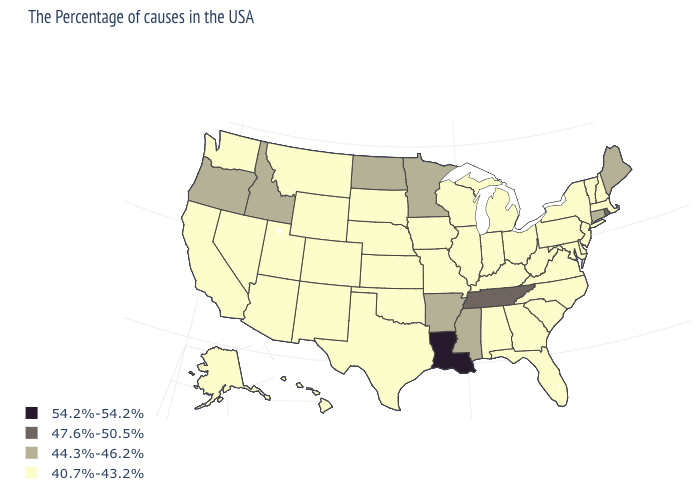Which states have the lowest value in the West?
Give a very brief answer. Wyoming, Colorado, New Mexico, Utah, Montana, Arizona, Nevada, California, Washington, Alaska, Hawaii. What is the value of Ohio?
Write a very short answer. 40.7%-43.2%. Name the states that have a value in the range 40.7%-43.2%?
Short answer required. Massachusetts, New Hampshire, Vermont, New York, New Jersey, Delaware, Maryland, Pennsylvania, Virginia, North Carolina, South Carolina, West Virginia, Ohio, Florida, Georgia, Michigan, Kentucky, Indiana, Alabama, Wisconsin, Illinois, Missouri, Iowa, Kansas, Nebraska, Oklahoma, Texas, South Dakota, Wyoming, Colorado, New Mexico, Utah, Montana, Arizona, Nevada, California, Washington, Alaska, Hawaii. How many symbols are there in the legend?
Short answer required. 4. Among the states that border Tennessee , which have the lowest value?
Answer briefly. Virginia, North Carolina, Georgia, Kentucky, Alabama, Missouri. Name the states that have a value in the range 40.7%-43.2%?
Give a very brief answer. Massachusetts, New Hampshire, Vermont, New York, New Jersey, Delaware, Maryland, Pennsylvania, Virginia, North Carolina, South Carolina, West Virginia, Ohio, Florida, Georgia, Michigan, Kentucky, Indiana, Alabama, Wisconsin, Illinois, Missouri, Iowa, Kansas, Nebraska, Oklahoma, Texas, South Dakota, Wyoming, Colorado, New Mexico, Utah, Montana, Arizona, Nevada, California, Washington, Alaska, Hawaii. Does Connecticut have a lower value than Oklahoma?
Answer briefly. No. Does Mississippi have a lower value than Louisiana?
Short answer required. Yes. Name the states that have a value in the range 54.2%-54.2%?
Short answer required. Louisiana. Name the states that have a value in the range 44.3%-46.2%?
Answer briefly. Maine, Connecticut, Mississippi, Arkansas, Minnesota, North Dakota, Idaho, Oregon. What is the value of Missouri?
Quick response, please. 40.7%-43.2%. What is the value of New Hampshire?
Answer briefly. 40.7%-43.2%. Does Kansas have the same value as North Dakota?
Keep it brief. No. Does Maine have the lowest value in the USA?
Answer briefly. No. What is the highest value in the USA?
Concise answer only. 54.2%-54.2%. 